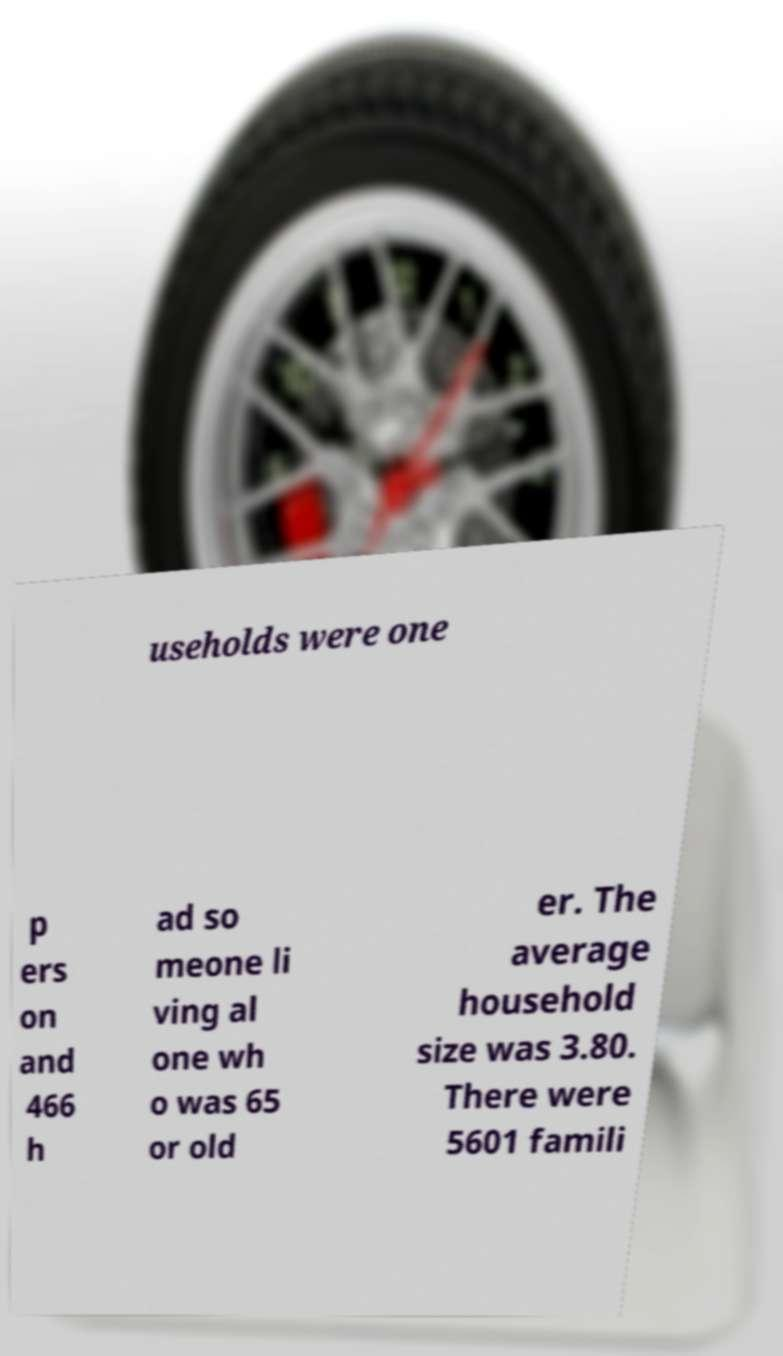For documentation purposes, I need the text within this image transcribed. Could you provide that? useholds were one p ers on and 466 h ad so meone li ving al one wh o was 65 or old er. The average household size was 3.80. There were 5601 famili 